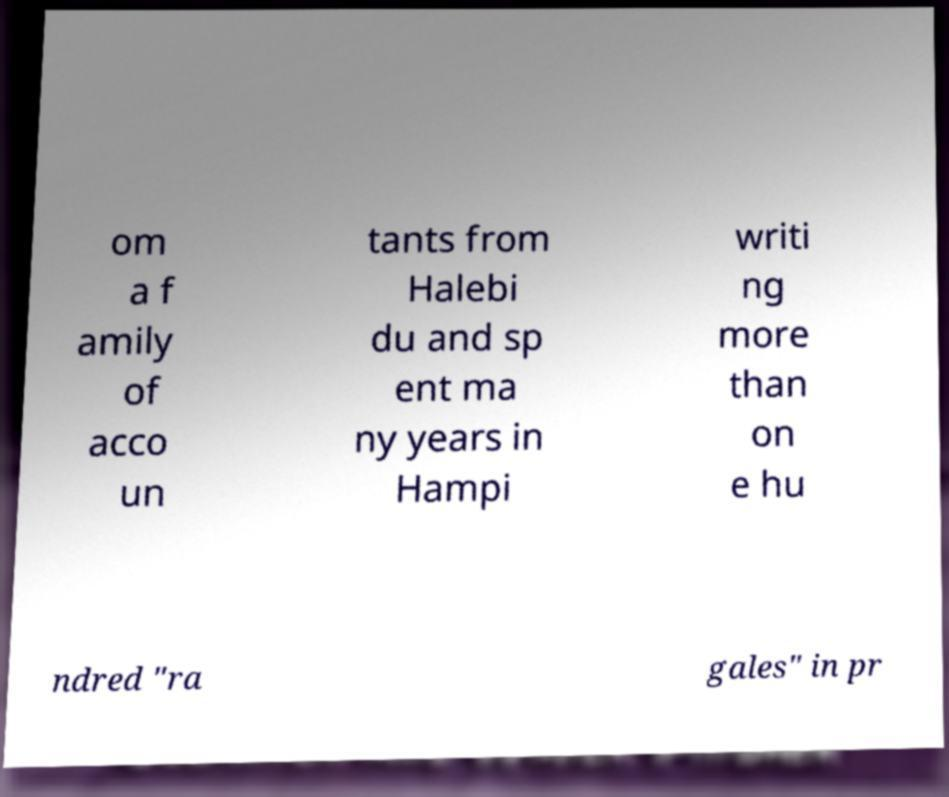For documentation purposes, I need the text within this image transcribed. Could you provide that? om a f amily of acco un tants from Halebi du and sp ent ma ny years in Hampi writi ng more than on e hu ndred "ra gales" in pr 